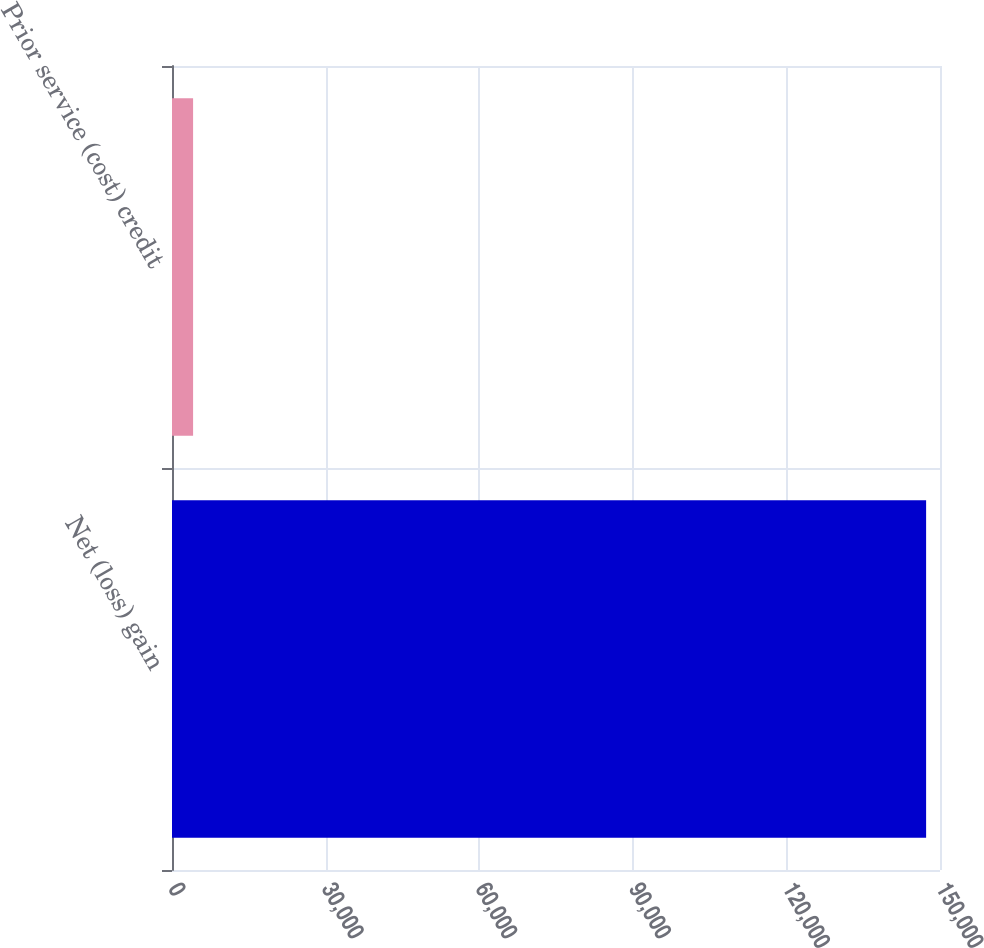Convert chart. <chart><loc_0><loc_0><loc_500><loc_500><bar_chart><fcel>Net (loss) gain<fcel>Prior service (cost) credit<nl><fcel>147288<fcel>4119<nl></chart> 